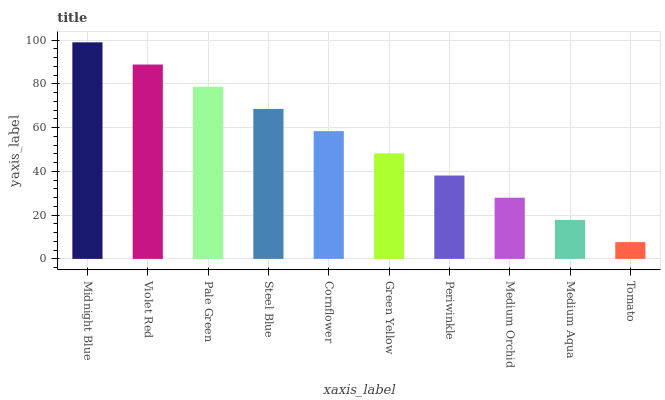Is Violet Red the minimum?
Answer yes or no. No. Is Violet Red the maximum?
Answer yes or no. No. Is Midnight Blue greater than Violet Red?
Answer yes or no. Yes. Is Violet Red less than Midnight Blue?
Answer yes or no. Yes. Is Violet Red greater than Midnight Blue?
Answer yes or no. No. Is Midnight Blue less than Violet Red?
Answer yes or no. No. Is Cornflower the high median?
Answer yes or no. Yes. Is Green Yellow the low median?
Answer yes or no. Yes. Is Periwinkle the high median?
Answer yes or no. No. Is Violet Red the low median?
Answer yes or no. No. 